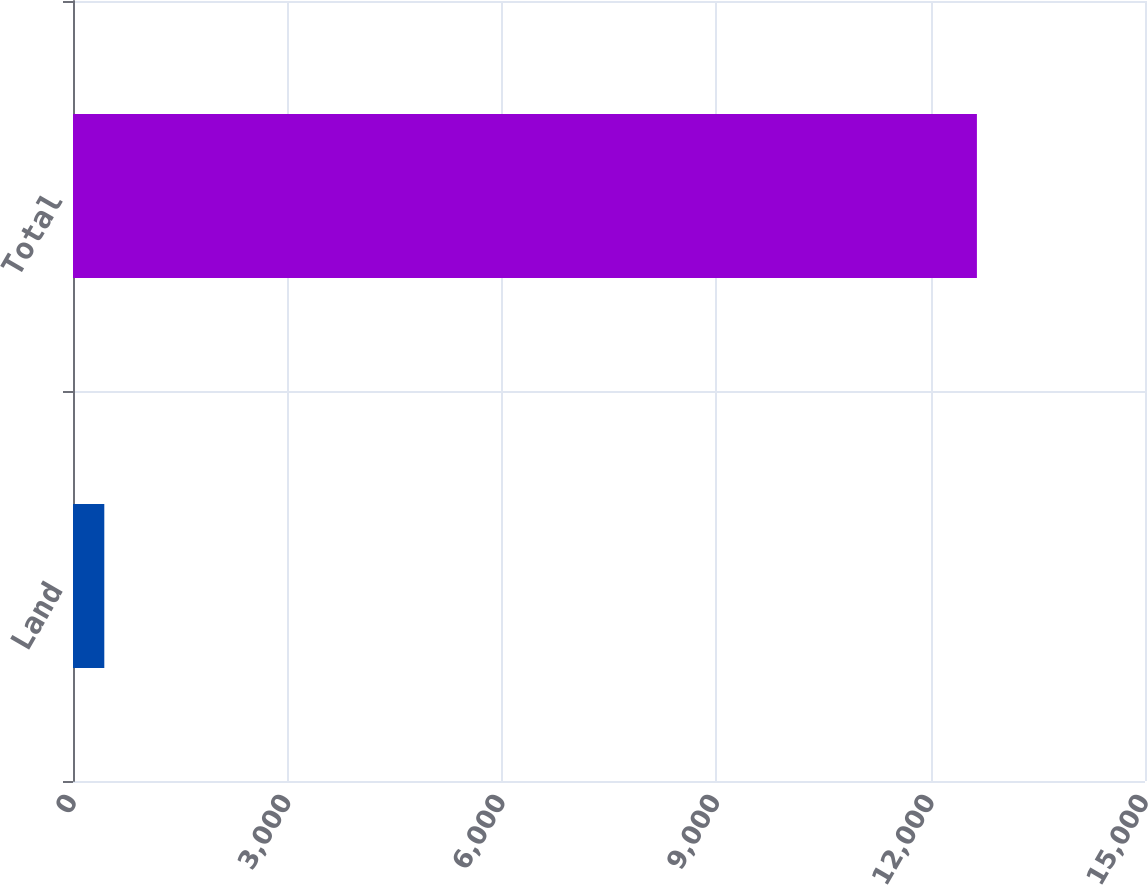Convert chart to OTSL. <chart><loc_0><loc_0><loc_500><loc_500><bar_chart><fcel>Land<fcel>Total<nl><fcel>438<fcel>12648<nl></chart> 